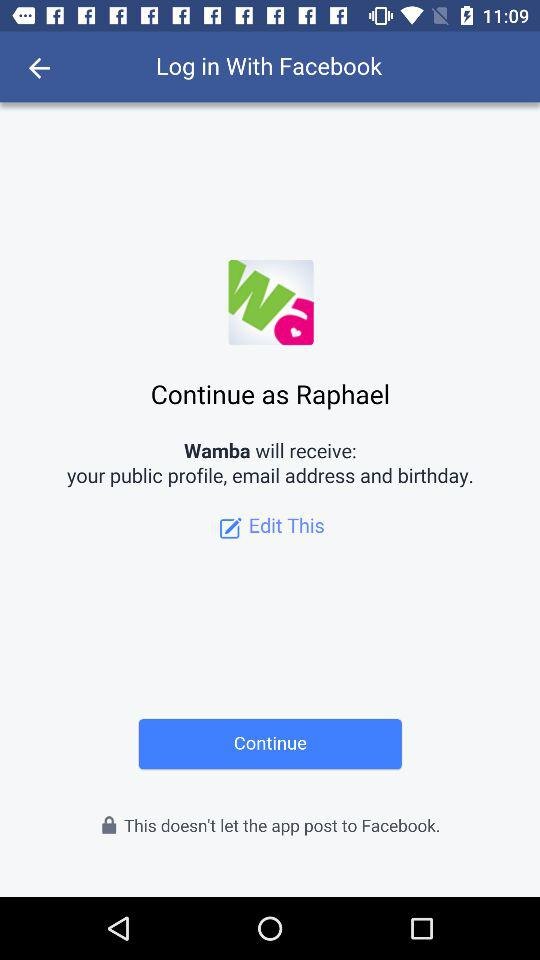What is the user name to continue with the profile? The user name to continue with the profile is Raphael. 